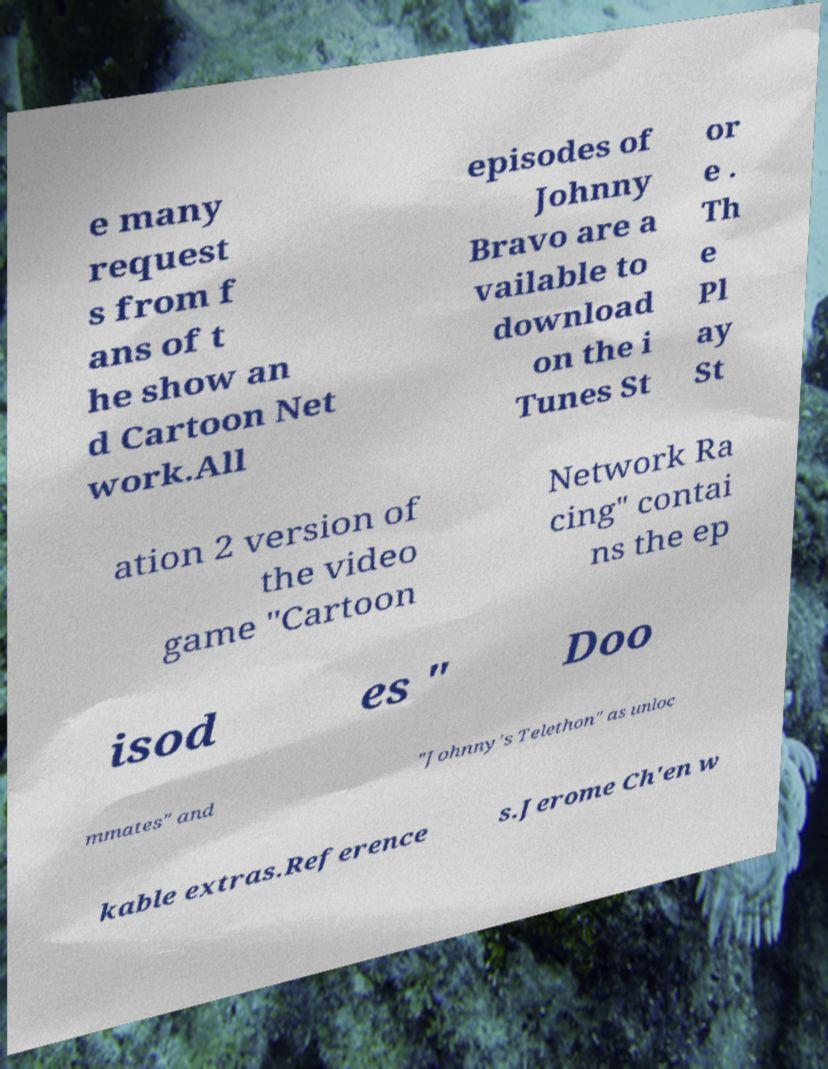Can you accurately transcribe the text from the provided image for me? e many request s from f ans of t he show an d Cartoon Net work.All episodes of Johnny Bravo are a vailable to download on the i Tunes St or e . Th e Pl ay St ation 2 version of the video game "Cartoon Network Ra cing" contai ns the ep isod es " Doo mmates" and "Johnny's Telethon" as unloc kable extras.Reference s.Jerome Ch'en w 